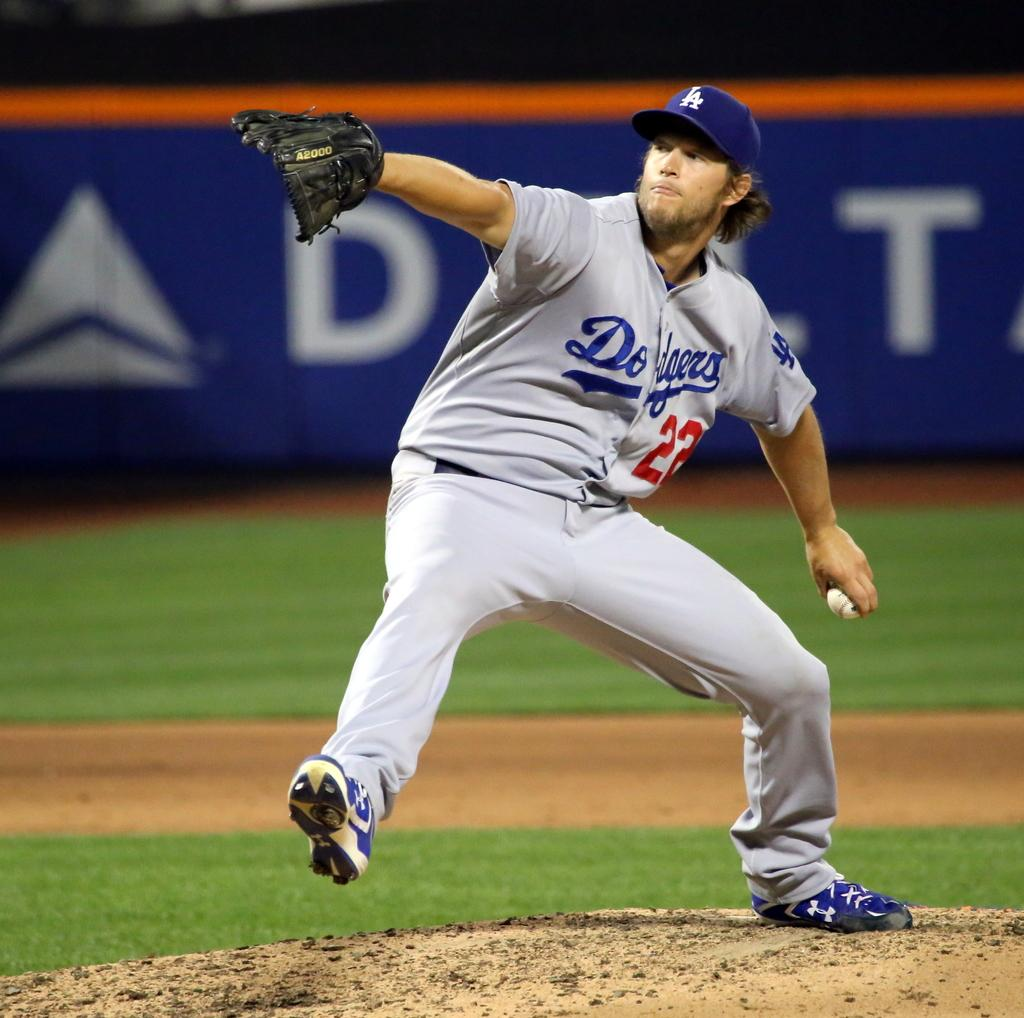<image>
Describe the image concisely. A baseball player with the number 22 on his shirt 